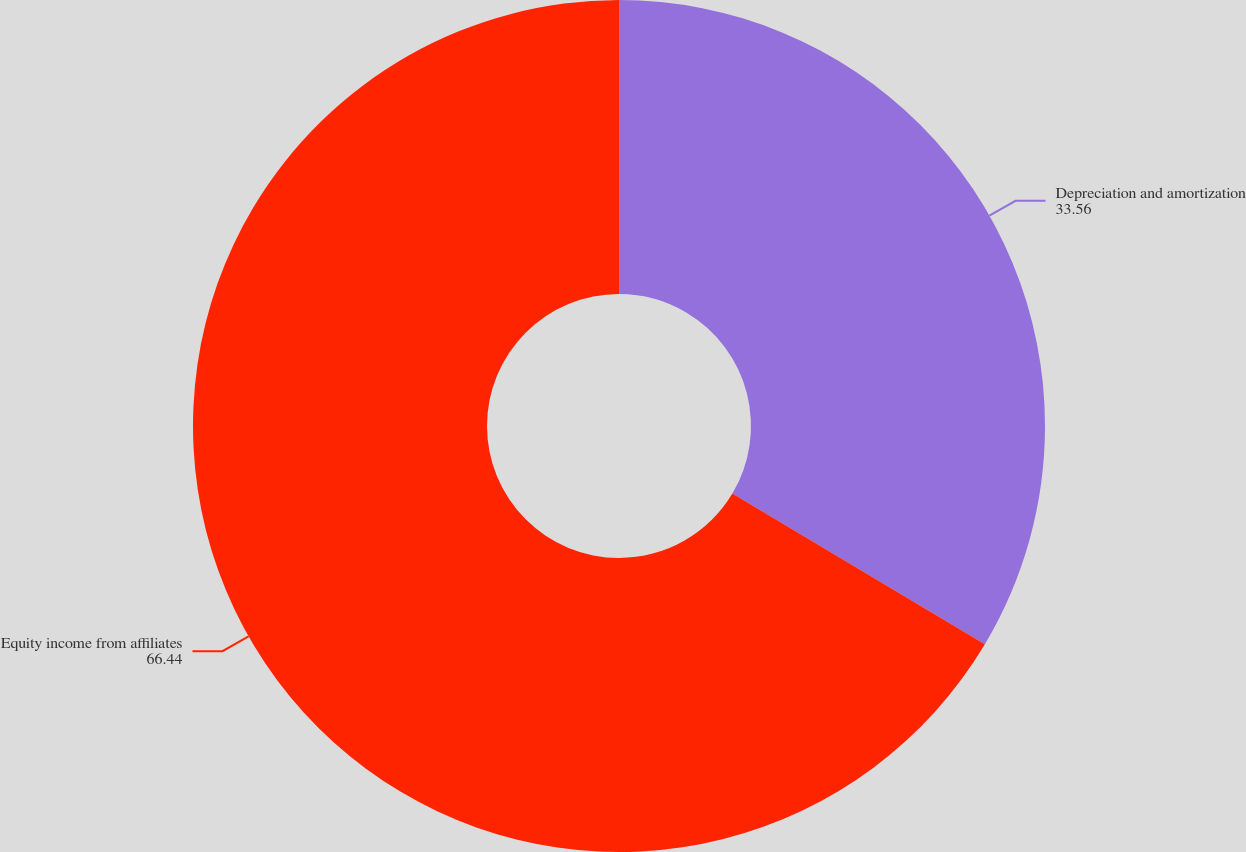<chart> <loc_0><loc_0><loc_500><loc_500><pie_chart><fcel>Depreciation and amortization<fcel>Equity income from affiliates<nl><fcel>33.56%<fcel>66.44%<nl></chart> 